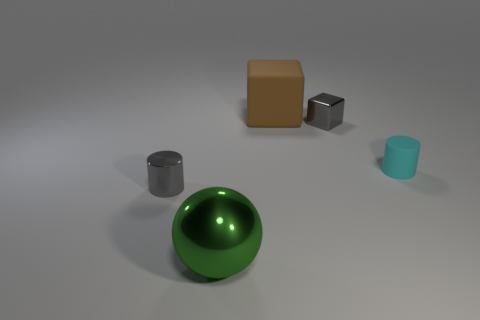Add 1 large shiny balls. How many objects exist? 6 Subtract 2 blocks. How many blocks are left? 0 Subtract all red cubes. How many gray cylinders are left? 1 Subtract all rubber cubes. Subtract all metal things. How many objects are left? 1 Add 2 gray metal cubes. How many gray metal cubes are left? 3 Add 3 big metallic objects. How many big metallic objects exist? 4 Subtract 0 blue cylinders. How many objects are left? 5 Subtract all cylinders. How many objects are left? 3 Subtract all green cylinders. Subtract all cyan cubes. How many cylinders are left? 2 